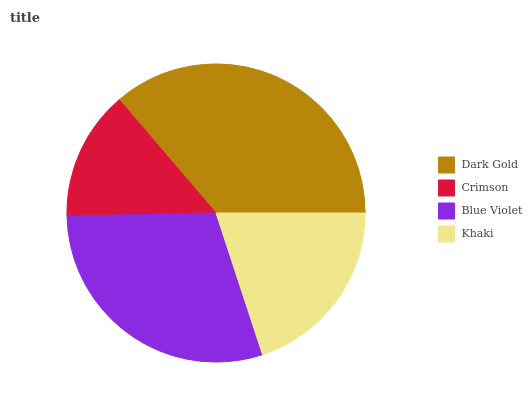Is Crimson the minimum?
Answer yes or no. Yes. Is Dark Gold the maximum?
Answer yes or no. Yes. Is Blue Violet the minimum?
Answer yes or no. No. Is Blue Violet the maximum?
Answer yes or no. No. Is Blue Violet greater than Crimson?
Answer yes or no. Yes. Is Crimson less than Blue Violet?
Answer yes or no. Yes. Is Crimson greater than Blue Violet?
Answer yes or no. No. Is Blue Violet less than Crimson?
Answer yes or no. No. Is Blue Violet the high median?
Answer yes or no. Yes. Is Khaki the low median?
Answer yes or no. Yes. Is Khaki the high median?
Answer yes or no. No. Is Dark Gold the low median?
Answer yes or no. No. 